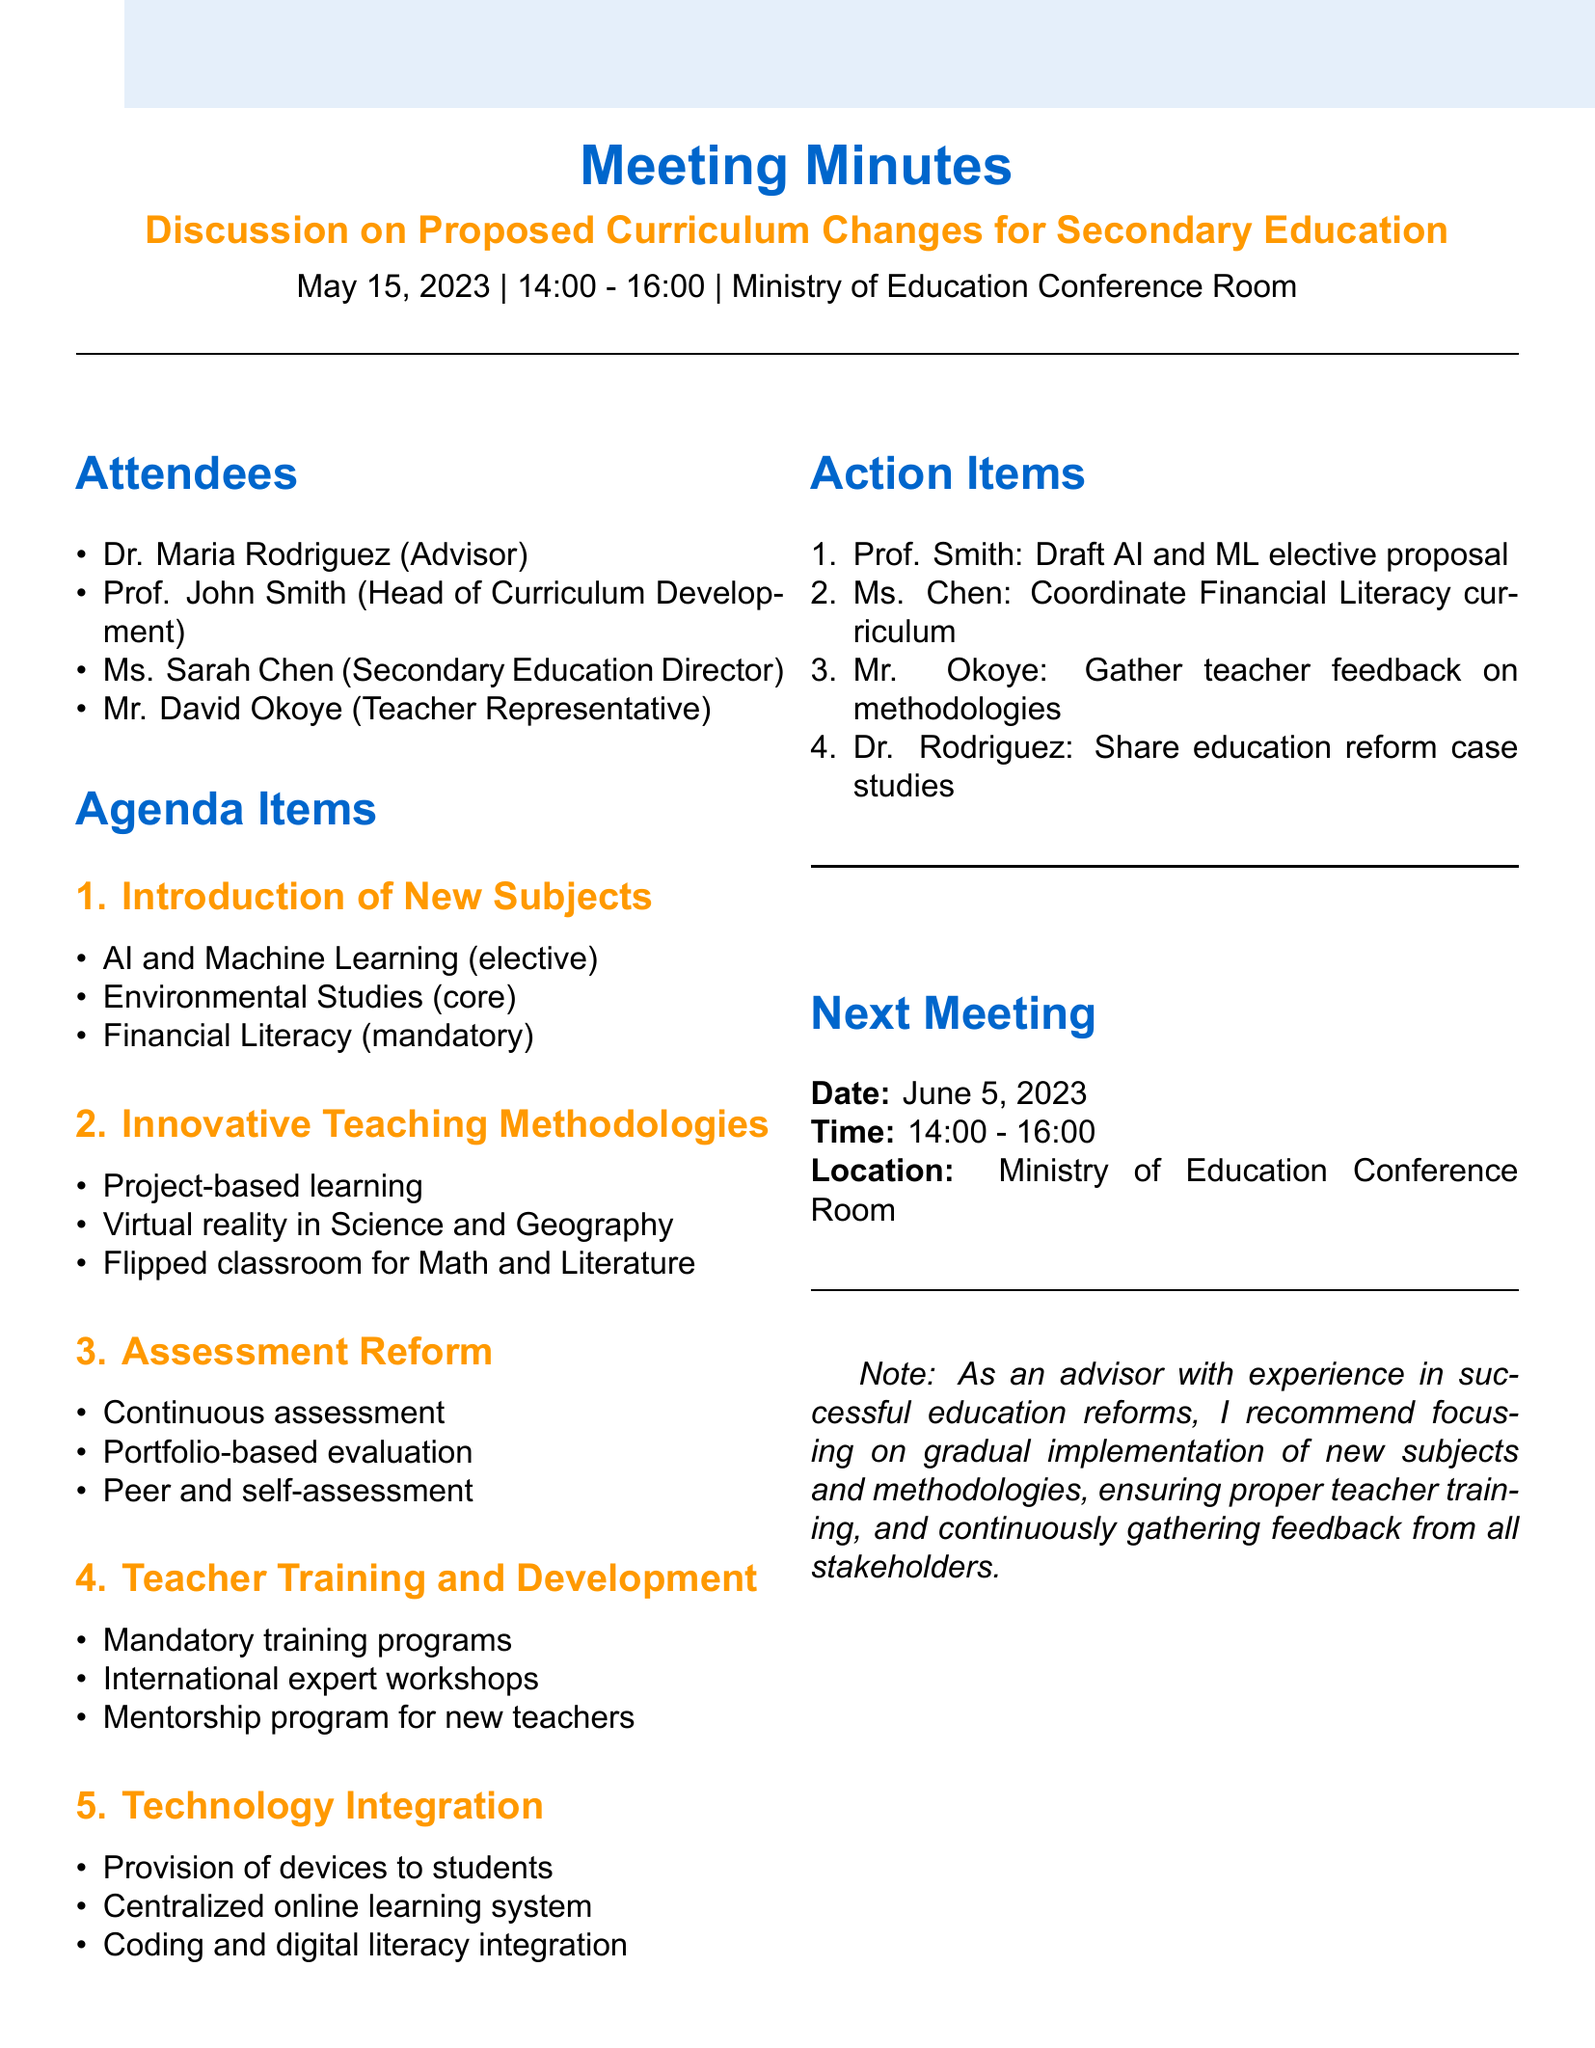What is the date of the meeting? The date of the meeting is explicitly mentioned in the document as May 15, 2023.
Answer: May 15, 2023 Who is the Secondary Education Director? This information can be found in the list of attendees where Ms. Sarah Chen is listed as the Secondary Education Director.
Answer: Ms. Sarah Chen What are the two new subjects proposed for introduction? The document lists three subjects, but two of them are Artificial Intelligence and Environmental Studies.
Answer: Artificial Intelligence, Environmental Studies What teaching methodology is planned to be mandatory for teacher training? The document mentions "Mandatory training programs on new teaching methodologies" for teacher training.
Answer: Mandatory training programs How many action items are listed? The action items section indicates four specific tasks assigned to attendees, which can be counted from the enumerated list.
Answer: Four What is the location for the next meeting? The location for the next meeting is provided in the next meeting section of the document, which mentions the Ministry of Education Conference Room.
Answer: Ministry of Education Conference Room What is the time for the next meeting? The time for the next meeting is clearly stated in the document as 14:00 - 16:00.
Answer: 14:00 - 16:00 Which subject's elective proposal is Prof. Smith tasked to draft? The document explicitly states that Prof. Smith is to draft a proposal for the AI and ML elective subject.
Answer: AI and ML elective What assessment reform technique is being introduced for arts and humanities? The document highlights the introduction of portfolio-based evaluation specifically for arts and humanities.
Answer: Portfolio-based evaluation 